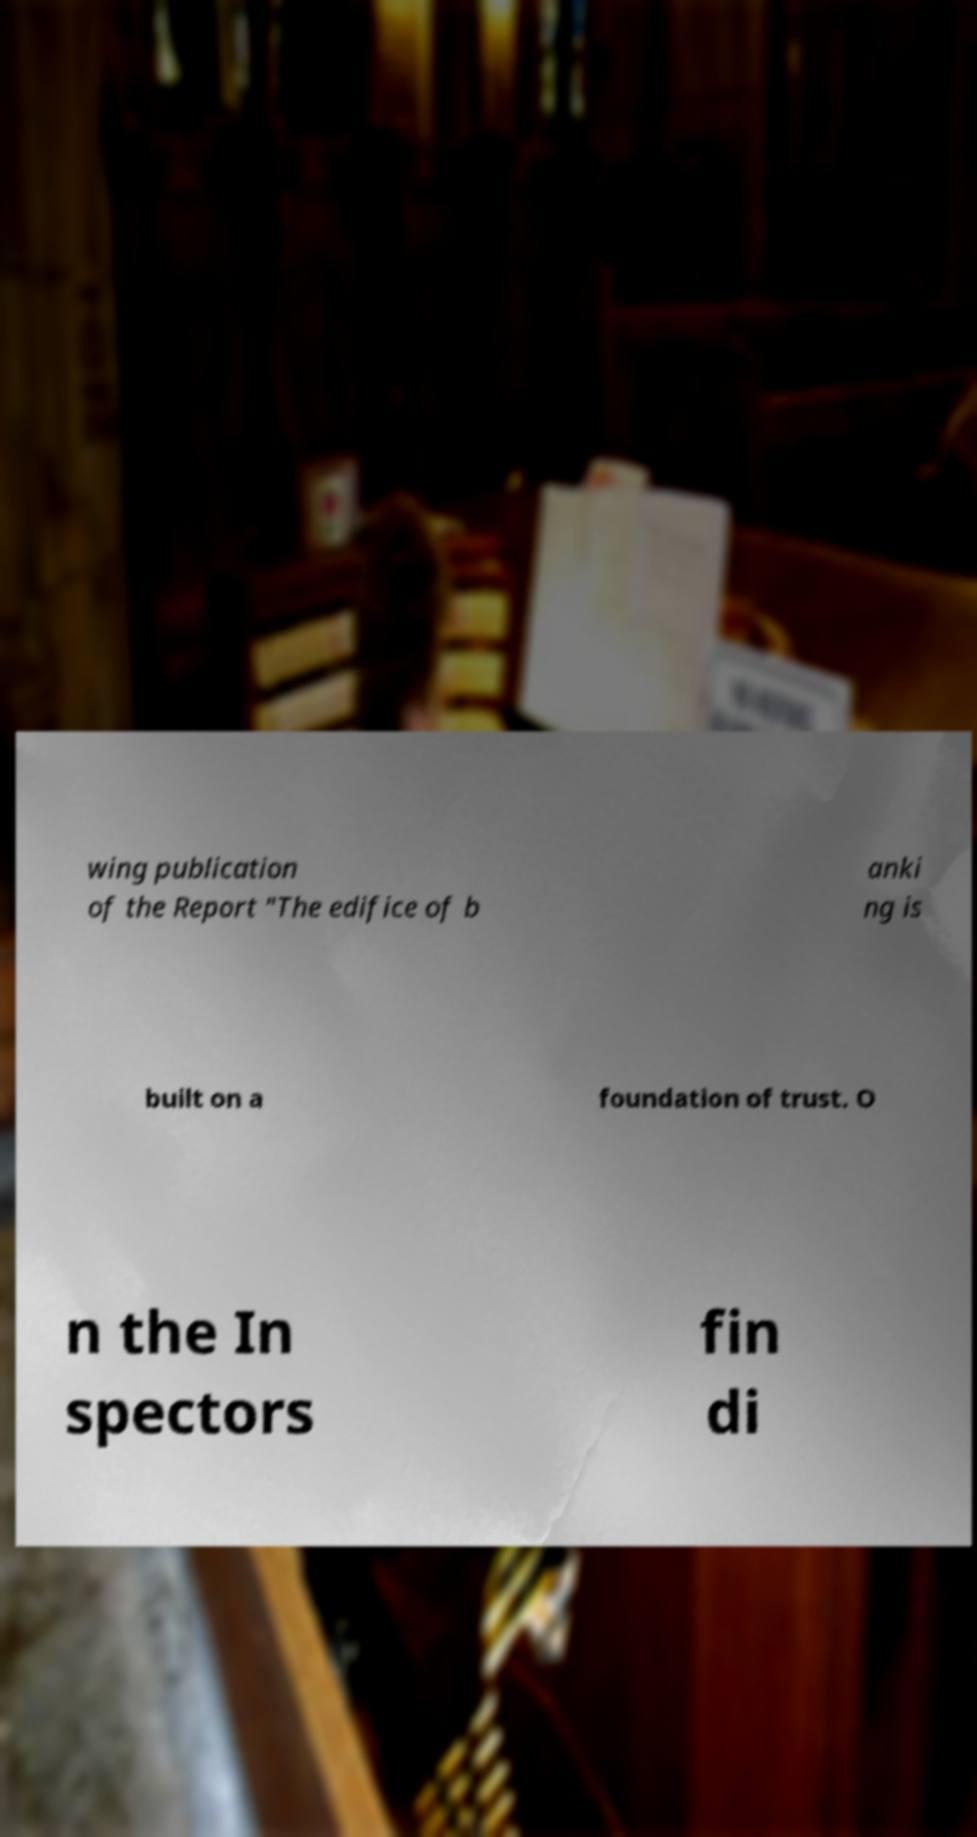Please identify and transcribe the text found in this image. wing publication of the Report "The edifice of b anki ng is built on a foundation of trust. O n the In spectors fin di 